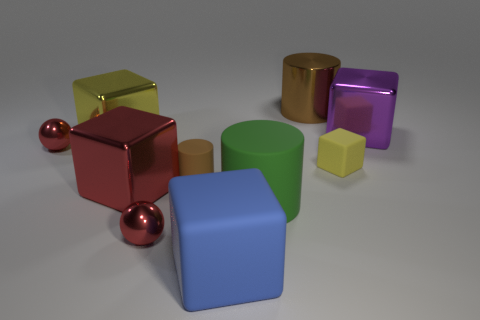What is the material of the other block that is the same color as the tiny matte cube?
Make the answer very short. Metal. Do the tiny brown object and the brown thing that is right of the brown rubber thing have the same shape?
Your response must be concise. Yes. Is the number of large blue blocks greater than the number of gray metallic cubes?
Keep it short and to the point. Yes. Is there anything else that has the same size as the purple cube?
Your answer should be compact. Yes. There is a tiny matte object that is left of the blue object; is it the same shape as the big purple metal object?
Your answer should be compact. No. Are there more big purple cubes on the left side of the large red shiny object than shiny cylinders?
Make the answer very short. No. There is a tiny metal sphere on the right side of the yellow block to the left of the big rubber cylinder; what color is it?
Give a very brief answer. Red. What number of brown shiny cubes are there?
Provide a succinct answer. 0. What number of cubes are in front of the big rubber cylinder and right of the large green rubber object?
Give a very brief answer. 0. Is there anything else that is the same shape as the blue thing?
Provide a succinct answer. Yes. 